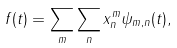Convert formula to latex. <formula><loc_0><loc_0><loc_500><loc_500>f ( t ) = \sum _ { m } \sum _ { n } x _ { n } ^ { m } \psi _ { m , n } ( t ) ,</formula> 